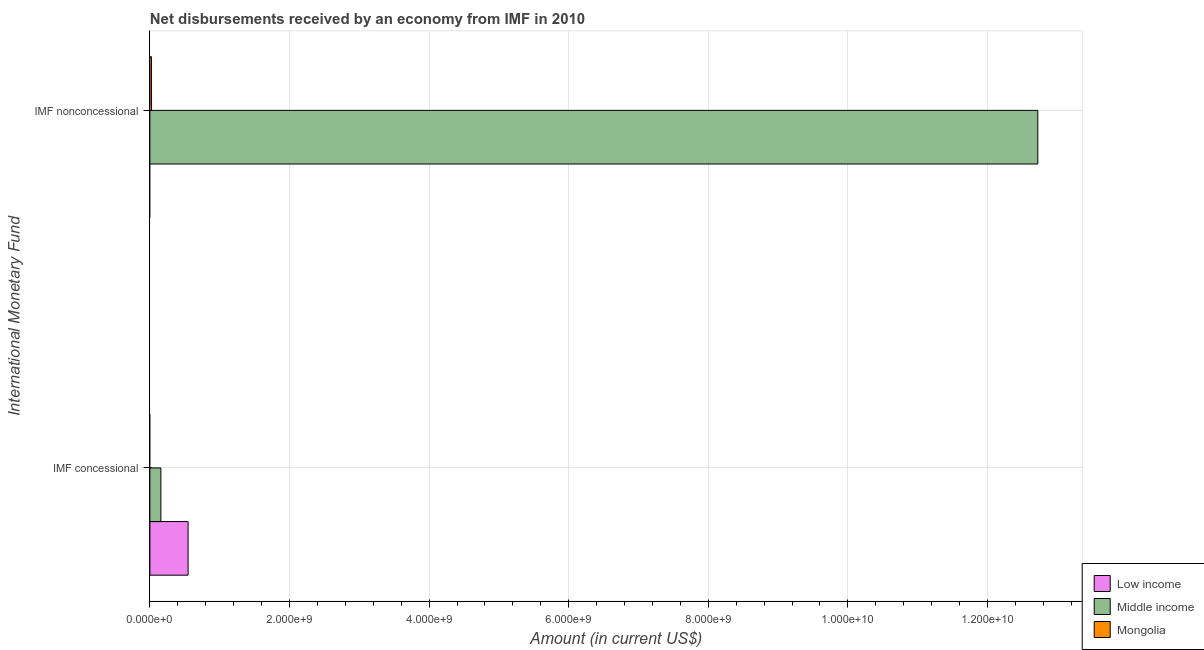How many groups of bars are there?
Keep it short and to the point. 2. Are the number of bars per tick equal to the number of legend labels?
Make the answer very short. No. Are the number of bars on each tick of the Y-axis equal?
Your response must be concise. Yes. How many bars are there on the 2nd tick from the top?
Ensure brevity in your answer.  2. What is the label of the 1st group of bars from the top?
Your answer should be very brief. IMF nonconcessional. What is the net concessional disbursements from imf in Middle income?
Your answer should be very brief. 1.57e+08. Across all countries, what is the maximum net concessional disbursements from imf?
Your response must be concise. 5.47e+08. Across all countries, what is the minimum net non concessional disbursements from imf?
Your response must be concise. 0. In which country was the net non concessional disbursements from imf maximum?
Provide a short and direct response. Middle income. What is the total net non concessional disbursements from imf in the graph?
Your response must be concise. 1.27e+1. What is the difference between the net concessional disbursements from imf in Low income and that in Middle income?
Give a very brief answer. 3.90e+08. What is the difference between the net concessional disbursements from imf in Low income and the net non concessional disbursements from imf in Mongolia?
Ensure brevity in your answer.  5.24e+08. What is the average net non concessional disbursements from imf per country?
Give a very brief answer. 4.25e+09. What is the difference between the net non concessional disbursements from imf and net concessional disbursements from imf in Middle income?
Provide a short and direct response. 1.26e+1. What is the ratio of the net concessional disbursements from imf in Low income to that in Middle income?
Your answer should be very brief. 3.48. How many bars are there?
Offer a terse response. 4. How many countries are there in the graph?
Make the answer very short. 3. Does the graph contain any zero values?
Offer a terse response. Yes. Does the graph contain grids?
Offer a terse response. Yes. How are the legend labels stacked?
Your response must be concise. Vertical. What is the title of the graph?
Your response must be concise. Net disbursements received by an economy from IMF in 2010. What is the label or title of the X-axis?
Offer a terse response. Amount (in current US$). What is the label or title of the Y-axis?
Provide a succinct answer. International Monetary Fund. What is the Amount (in current US$) of Low income in IMF concessional?
Offer a terse response. 5.47e+08. What is the Amount (in current US$) in Middle income in IMF concessional?
Your answer should be very brief. 1.57e+08. What is the Amount (in current US$) in Mongolia in IMF concessional?
Make the answer very short. 0. What is the Amount (in current US$) of Middle income in IMF nonconcessional?
Give a very brief answer. 1.27e+1. What is the Amount (in current US$) in Mongolia in IMF nonconcessional?
Your answer should be compact. 2.34e+07. Across all International Monetary Fund, what is the maximum Amount (in current US$) of Low income?
Offer a very short reply. 5.47e+08. Across all International Monetary Fund, what is the maximum Amount (in current US$) of Middle income?
Make the answer very short. 1.27e+1. Across all International Monetary Fund, what is the maximum Amount (in current US$) in Mongolia?
Your response must be concise. 2.34e+07. Across all International Monetary Fund, what is the minimum Amount (in current US$) of Middle income?
Your answer should be compact. 1.57e+08. What is the total Amount (in current US$) in Low income in the graph?
Offer a terse response. 5.47e+08. What is the total Amount (in current US$) in Middle income in the graph?
Offer a terse response. 1.29e+1. What is the total Amount (in current US$) in Mongolia in the graph?
Make the answer very short. 2.34e+07. What is the difference between the Amount (in current US$) of Middle income in IMF concessional and that in IMF nonconcessional?
Provide a succinct answer. -1.26e+1. What is the difference between the Amount (in current US$) in Low income in IMF concessional and the Amount (in current US$) in Middle income in IMF nonconcessional?
Keep it short and to the point. -1.22e+1. What is the difference between the Amount (in current US$) in Low income in IMF concessional and the Amount (in current US$) in Mongolia in IMF nonconcessional?
Your response must be concise. 5.24e+08. What is the difference between the Amount (in current US$) in Middle income in IMF concessional and the Amount (in current US$) in Mongolia in IMF nonconcessional?
Your answer should be compact. 1.34e+08. What is the average Amount (in current US$) of Low income per International Monetary Fund?
Offer a terse response. 2.74e+08. What is the average Amount (in current US$) in Middle income per International Monetary Fund?
Your response must be concise. 6.44e+09. What is the average Amount (in current US$) of Mongolia per International Monetary Fund?
Your response must be concise. 1.17e+07. What is the difference between the Amount (in current US$) in Low income and Amount (in current US$) in Middle income in IMF concessional?
Give a very brief answer. 3.90e+08. What is the difference between the Amount (in current US$) in Middle income and Amount (in current US$) in Mongolia in IMF nonconcessional?
Offer a terse response. 1.27e+1. What is the ratio of the Amount (in current US$) of Middle income in IMF concessional to that in IMF nonconcessional?
Make the answer very short. 0.01. What is the difference between the highest and the second highest Amount (in current US$) in Middle income?
Offer a very short reply. 1.26e+1. What is the difference between the highest and the lowest Amount (in current US$) of Low income?
Keep it short and to the point. 5.47e+08. What is the difference between the highest and the lowest Amount (in current US$) of Middle income?
Your answer should be compact. 1.26e+1. What is the difference between the highest and the lowest Amount (in current US$) in Mongolia?
Provide a succinct answer. 2.34e+07. 